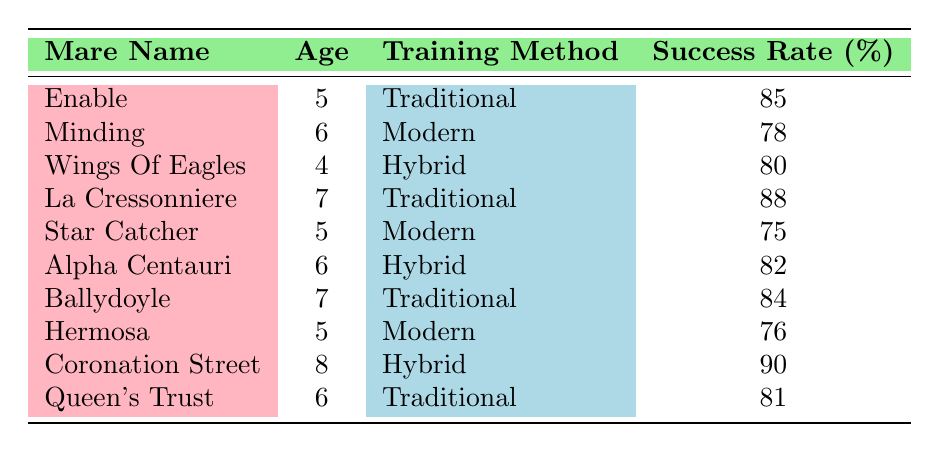What is the success rate of Enable? Looking at the entry for Enable in the table, the success rate is listed directly in the corresponding row.
Answer: 85 Which mare has the highest success rate, and what is it? By scanning the success rates in the table, Coronation Street has the highest success rate listed at 90.
Answer: Coronation Street, 90 How many mares have a success rate of 80 or higher? By reviewing the table, the mares with a success rate of 80 or higher are Enable, La Cressonniere, Coronation Street, and Alpha Centauri. There are a total of 4 mares meeting this criteria.
Answer: 4 What is the average success rate of mares trained using the Modern method? The success rates for mares trained with the Modern method are 78 (Minding), 75 (Star Catcher), and 76 (Hermosa). Summing these gives 78 + 75 + 76 = 229, and dividing by 3 (the number of Modern-trained mares) gives an average of 76.33.
Answer: 76.33 Is it true that all mares aged 7 are trained using Traditional methods? Looking at the table, both La Cressonniere and Ballydoyle are aged 7 and both have the Traditional training method listed. Thus, it’s true.
Answer: Yes Which training method corresponds to the mare with the lowest success rate? By identifying which mare has the lowest success rate listed, it is Star Catcher at 75, who is trained with the Modern method.
Answer: Modern What is the median success rate of mares aged 6? The mares aged 6 are Minding, Alpha Centauri, and Queen's Trust with success rates of 78, 82, and 81 respectively. Arranging these in order gives 78, 81, 82. The median is the middle value, which is 81.
Answer: 81 What is the difference in success rates between the youngest and oldest mares? The youngest mare, Wings Of Eagles, has a success rate of 80, while the oldest mare, Coronation Street, has a success rate of 90. The difference is 90 - 80 = 10.
Answer: 10 How many mares are older than 5 years and trained using a Hybrid training method? From the table, the only mare older than 5 years and trained using a Hybrid method is Coronation Street, who is 8 years old. Thus, there is 1 mare fitting this category.
Answer: 1 